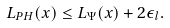Convert formula to latex. <formula><loc_0><loc_0><loc_500><loc_500>L _ { P H } ( x ) \leq L _ { \Psi } ( x ) + 2 \epsilon _ { l } .</formula> 